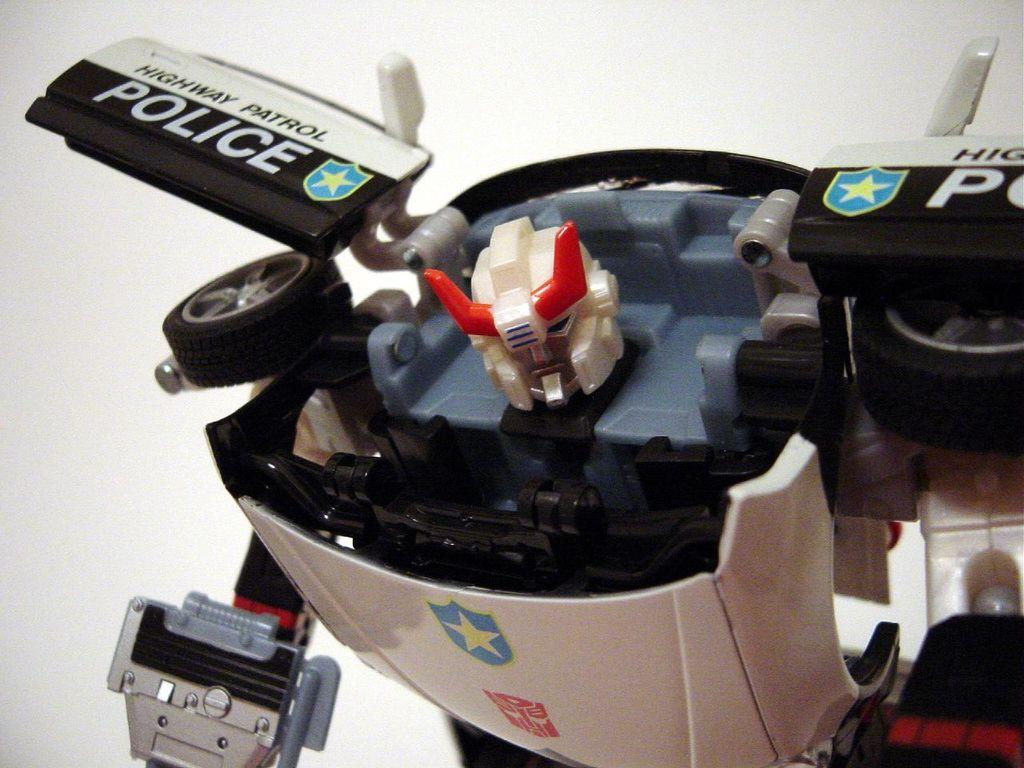What is the main subject of the image? There is a robot in the image. What else can be seen in the image besides the robot? There is printed text in the image. Where is the rest area for the robot in the image? There is no rest area for the robot in the image, as it is a static image and not a real-life scenario. 